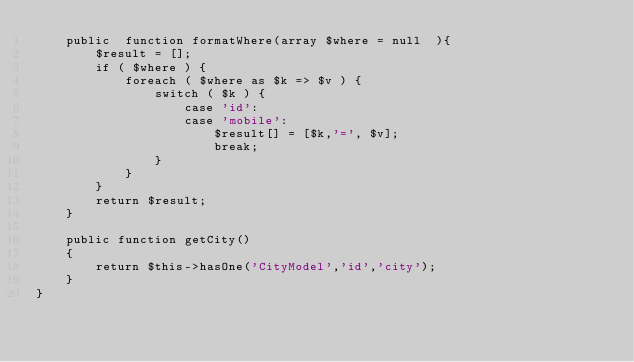Convert code to text. <code><loc_0><loc_0><loc_500><loc_500><_PHP_>    public  function formatWhere(array $where = null  ){
        $result = [];
        if ( $where ) {
            foreach ( $where as $k => $v ) {
                switch ( $k ) {
                    case 'id':
                    case 'mobile':
                        $result[] = [$k,'=', $v];
                        break;
                }
            }
        }
        return $result;
    }

    public function getCity()
    {
        return $this->hasOne('CityModel','id','city');
    }
}</code> 